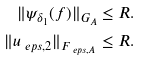Convert formula to latex. <formula><loc_0><loc_0><loc_500><loc_500>\| \psi _ { \delta _ { 1 } } ( f ) \| _ { G _ { A } } & \leq R . \\ \| u _ { \ e p s , 2 } \| _ { F _ { \ e p s , A } } & \leq R .</formula> 